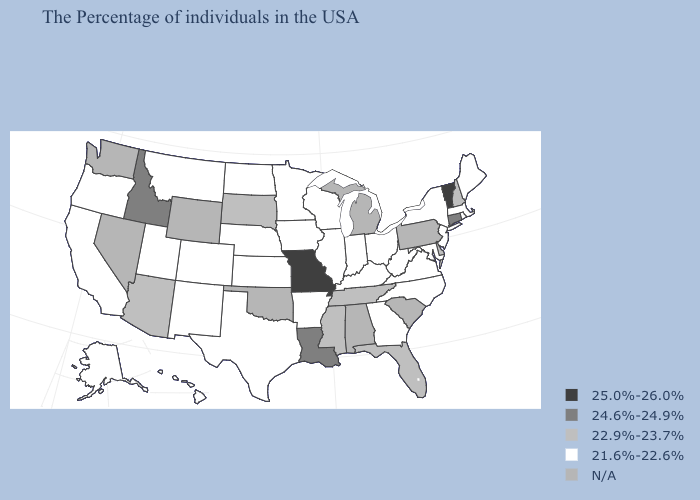Among the states that border North Dakota , which have the lowest value?
Concise answer only. Minnesota, Montana. What is the value of California?
Give a very brief answer. 21.6%-22.6%. What is the lowest value in the South?
Quick response, please. 21.6%-22.6%. What is the highest value in the West ?
Write a very short answer. 24.6%-24.9%. What is the value of New York?
Short answer required. 21.6%-22.6%. What is the value of Nebraska?
Quick response, please. 21.6%-22.6%. Which states have the lowest value in the MidWest?
Short answer required. Ohio, Indiana, Wisconsin, Illinois, Minnesota, Iowa, Kansas, Nebraska, North Dakota. How many symbols are there in the legend?
Write a very short answer. 5. Which states have the lowest value in the MidWest?
Keep it brief. Ohio, Indiana, Wisconsin, Illinois, Minnesota, Iowa, Kansas, Nebraska, North Dakota. What is the value of Connecticut?
Concise answer only. 24.6%-24.9%. Name the states that have a value in the range N/A?
Quick response, please. Pennsylvania, South Carolina, Michigan, Alabama, Oklahoma, Wyoming, Nevada, Washington. What is the lowest value in the USA?
Concise answer only. 21.6%-22.6%. What is the value of Minnesota?
Concise answer only. 21.6%-22.6%. 